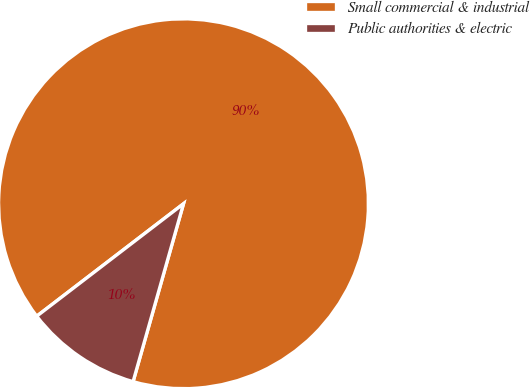Convert chart to OTSL. <chart><loc_0><loc_0><loc_500><loc_500><pie_chart><fcel>Small commercial & industrial<fcel>Public authorities & electric<nl><fcel>89.8%<fcel>10.2%<nl></chart> 